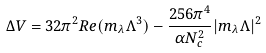Convert formula to latex. <formula><loc_0><loc_0><loc_500><loc_500>\Delta V = 3 2 \pi ^ { 2 } R e ( m _ { \lambda } \Lambda ^ { 3 } ) - \frac { 2 5 6 \pi ^ { 4 } } { \alpha N _ { c } ^ { 2 } } | m _ { \lambda } \Lambda | ^ { 2 }</formula> 